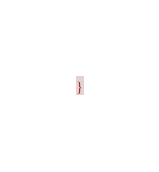Convert code to text. <code><loc_0><loc_0><loc_500><loc_500><_CSS_>}
</code> 